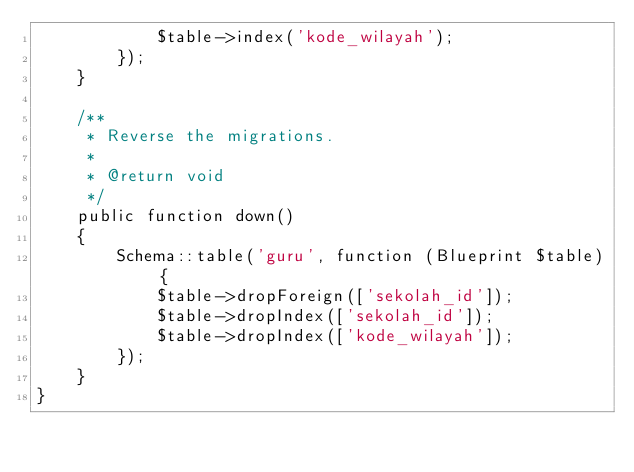<code> <loc_0><loc_0><loc_500><loc_500><_PHP_>			$table->index('kode_wilayah');
        });
    }

    /**
     * Reverse the migrations.
     *
     * @return void
     */
    public function down()
    {
        Schema::table('guru', function (Blueprint $table) {
			$table->dropForeign(['sekolah_id']);
            $table->dropIndex(['sekolah_id']);
			$table->dropIndex(['kode_wilayah']);
        });
    }
}
</code> 